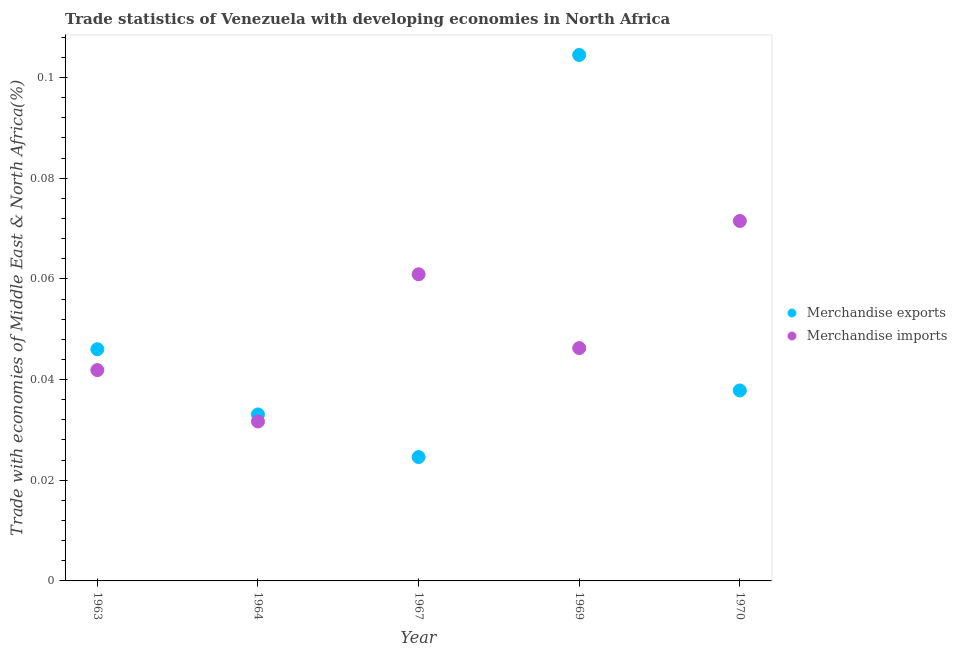What is the merchandise imports in 1969?
Give a very brief answer. 0.05. Across all years, what is the maximum merchandise exports?
Your answer should be very brief. 0.1. Across all years, what is the minimum merchandise imports?
Your answer should be very brief. 0.03. In which year was the merchandise exports maximum?
Keep it short and to the point. 1969. In which year was the merchandise exports minimum?
Ensure brevity in your answer.  1967. What is the total merchandise exports in the graph?
Make the answer very short. 0.25. What is the difference between the merchandise imports in 1967 and that in 1970?
Keep it short and to the point. -0.01. What is the difference between the merchandise exports in 1967 and the merchandise imports in 1970?
Your answer should be very brief. -0.05. What is the average merchandise imports per year?
Your answer should be compact. 0.05. In the year 1963, what is the difference between the merchandise imports and merchandise exports?
Ensure brevity in your answer.  -0. What is the ratio of the merchandise imports in 1967 to that in 1969?
Offer a terse response. 1.32. Is the merchandise exports in 1967 less than that in 1969?
Your answer should be compact. Yes. Is the difference between the merchandise exports in 1963 and 1970 greater than the difference between the merchandise imports in 1963 and 1970?
Your answer should be compact. Yes. What is the difference between the highest and the second highest merchandise exports?
Your response must be concise. 0.06. What is the difference between the highest and the lowest merchandise imports?
Your answer should be compact. 0.04. In how many years, is the merchandise exports greater than the average merchandise exports taken over all years?
Your answer should be compact. 1. Is the sum of the merchandise imports in 1967 and 1970 greater than the maximum merchandise exports across all years?
Your answer should be compact. Yes. Does the merchandise exports monotonically increase over the years?
Keep it short and to the point. No. Is the merchandise imports strictly greater than the merchandise exports over the years?
Give a very brief answer. No. Is the merchandise exports strictly less than the merchandise imports over the years?
Your response must be concise. No. Are the values on the major ticks of Y-axis written in scientific E-notation?
Your response must be concise. No. Does the graph contain any zero values?
Offer a very short reply. No. Does the graph contain grids?
Make the answer very short. No. How many legend labels are there?
Ensure brevity in your answer.  2. What is the title of the graph?
Give a very brief answer. Trade statistics of Venezuela with developing economies in North Africa. Does "constant 2005 US$" appear as one of the legend labels in the graph?
Give a very brief answer. No. What is the label or title of the Y-axis?
Ensure brevity in your answer.  Trade with economies of Middle East & North Africa(%). What is the Trade with economies of Middle East & North Africa(%) in Merchandise exports in 1963?
Your response must be concise. 0.05. What is the Trade with economies of Middle East & North Africa(%) in Merchandise imports in 1963?
Keep it short and to the point. 0.04. What is the Trade with economies of Middle East & North Africa(%) in Merchandise exports in 1964?
Make the answer very short. 0.03. What is the Trade with economies of Middle East & North Africa(%) of Merchandise imports in 1964?
Provide a short and direct response. 0.03. What is the Trade with economies of Middle East & North Africa(%) of Merchandise exports in 1967?
Provide a succinct answer. 0.02. What is the Trade with economies of Middle East & North Africa(%) in Merchandise imports in 1967?
Offer a terse response. 0.06. What is the Trade with economies of Middle East & North Africa(%) of Merchandise exports in 1969?
Your answer should be very brief. 0.1. What is the Trade with economies of Middle East & North Africa(%) in Merchandise imports in 1969?
Your answer should be very brief. 0.05. What is the Trade with economies of Middle East & North Africa(%) of Merchandise exports in 1970?
Offer a terse response. 0.04. What is the Trade with economies of Middle East & North Africa(%) of Merchandise imports in 1970?
Ensure brevity in your answer.  0.07. Across all years, what is the maximum Trade with economies of Middle East & North Africa(%) of Merchandise exports?
Provide a short and direct response. 0.1. Across all years, what is the maximum Trade with economies of Middle East & North Africa(%) in Merchandise imports?
Keep it short and to the point. 0.07. Across all years, what is the minimum Trade with economies of Middle East & North Africa(%) in Merchandise exports?
Ensure brevity in your answer.  0.02. Across all years, what is the minimum Trade with economies of Middle East & North Africa(%) in Merchandise imports?
Keep it short and to the point. 0.03. What is the total Trade with economies of Middle East & North Africa(%) of Merchandise exports in the graph?
Ensure brevity in your answer.  0.25. What is the total Trade with economies of Middle East & North Africa(%) of Merchandise imports in the graph?
Offer a very short reply. 0.25. What is the difference between the Trade with economies of Middle East & North Africa(%) of Merchandise exports in 1963 and that in 1964?
Your answer should be compact. 0.01. What is the difference between the Trade with economies of Middle East & North Africa(%) of Merchandise imports in 1963 and that in 1964?
Your response must be concise. 0.01. What is the difference between the Trade with economies of Middle East & North Africa(%) in Merchandise exports in 1963 and that in 1967?
Make the answer very short. 0.02. What is the difference between the Trade with economies of Middle East & North Africa(%) of Merchandise imports in 1963 and that in 1967?
Provide a succinct answer. -0.02. What is the difference between the Trade with economies of Middle East & North Africa(%) in Merchandise exports in 1963 and that in 1969?
Your answer should be compact. -0.06. What is the difference between the Trade with economies of Middle East & North Africa(%) in Merchandise imports in 1963 and that in 1969?
Keep it short and to the point. -0. What is the difference between the Trade with economies of Middle East & North Africa(%) of Merchandise exports in 1963 and that in 1970?
Offer a very short reply. 0.01. What is the difference between the Trade with economies of Middle East & North Africa(%) in Merchandise imports in 1963 and that in 1970?
Your response must be concise. -0.03. What is the difference between the Trade with economies of Middle East & North Africa(%) in Merchandise exports in 1964 and that in 1967?
Provide a succinct answer. 0.01. What is the difference between the Trade with economies of Middle East & North Africa(%) in Merchandise imports in 1964 and that in 1967?
Your answer should be very brief. -0.03. What is the difference between the Trade with economies of Middle East & North Africa(%) in Merchandise exports in 1964 and that in 1969?
Give a very brief answer. -0.07. What is the difference between the Trade with economies of Middle East & North Africa(%) of Merchandise imports in 1964 and that in 1969?
Offer a very short reply. -0.01. What is the difference between the Trade with economies of Middle East & North Africa(%) of Merchandise exports in 1964 and that in 1970?
Give a very brief answer. -0. What is the difference between the Trade with economies of Middle East & North Africa(%) in Merchandise imports in 1964 and that in 1970?
Make the answer very short. -0.04. What is the difference between the Trade with economies of Middle East & North Africa(%) in Merchandise exports in 1967 and that in 1969?
Ensure brevity in your answer.  -0.08. What is the difference between the Trade with economies of Middle East & North Africa(%) of Merchandise imports in 1967 and that in 1969?
Offer a terse response. 0.01. What is the difference between the Trade with economies of Middle East & North Africa(%) of Merchandise exports in 1967 and that in 1970?
Provide a succinct answer. -0.01. What is the difference between the Trade with economies of Middle East & North Africa(%) of Merchandise imports in 1967 and that in 1970?
Offer a terse response. -0.01. What is the difference between the Trade with economies of Middle East & North Africa(%) of Merchandise exports in 1969 and that in 1970?
Give a very brief answer. 0.07. What is the difference between the Trade with economies of Middle East & North Africa(%) of Merchandise imports in 1969 and that in 1970?
Your answer should be compact. -0.03. What is the difference between the Trade with economies of Middle East & North Africa(%) in Merchandise exports in 1963 and the Trade with economies of Middle East & North Africa(%) in Merchandise imports in 1964?
Keep it short and to the point. 0.01. What is the difference between the Trade with economies of Middle East & North Africa(%) of Merchandise exports in 1963 and the Trade with economies of Middle East & North Africa(%) of Merchandise imports in 1967?
Your response must be concise. -0.01. What is the difference between the Trade with economies of Middle East & North Africa(%) of Merchandise exports in 1963 and the Trade with economies of Middle East & North Africa(%) of Merchandise imports in 1969?
Keep it short and to the point. -0. What is the difference between the Trade with economies of Middle East & North Africa(%) of Merchandise exports in 1963 and the Trade with economies of Middle East & North Africa(%) of Merchandise imports in 1970?
Offer a very short reply. -0.03. What is the difference between the Trade with economies of Middle East & North Africa(%) in Merchandise exports in 1964 and the Trade with economies of Middle East & North Africa(%) in Merchandise imports in 1967?
Ensure brevity in your answer.  -0.03. What is the difference between the Trade with economies of Middle East & North Africa(%) of Merchandise exports in 1964 and the Trade with economies of Middle East & North Africa(%) of Merchandise imports in 1969?
Ensure brevity in your answer.  -0.01. What is the difference between the Trade with economies of Middle East & North Africa(%) in Merchandise exports in 1964 and the Trade with economies of Middle East & North Africa(%) in Merchandise imports in 1970?
Provide a succinct answer. -0.04. What is the difference between the Trade with economies of Middle East & North Africa(%) in Merchandise exports in 1967 and the Trade with economies of Middle East & North Africa(%) in Merchandise imports in 1969?
Provide a short and direct response. -0.02. What is the difference between the Trade with economies of Middle East & North Africa(%) in Merchandise exports in 1967 and the Trade with economies of Middle East & North Africa(%) in Merchandise imports in 1970?
Provide a succinct answer. -0.05. What is the difference between the Trade with economies of Middle East & North Africa(%) of Merchandise exports in 1969 and the Trade with economies of Middle East & North Africa(%) of Merchandise imports in 1970?
Offer a very short reply. 0.03. What is the average Trade with economies of Middle East & North Africa(%) of Merchandise exports per year?
Your answer should be very brief. 0.05. What is the average Trade with economies of Middle East & North Africa(%) of Merchandise imports per year?
Provide a succinct answer. 0.05. In the year 1963, what is the difference between the Trade with economies of Middle East & North Africa(%) in Merchandise exports and Trade with economies of Middle East & North Africa(%) in Merchandise imports?
Offer a terse response. 0. In the year 1964, what is the difference between the Trade with economies of Middle East & North Africa(%) of Merchandise exports and Trade with economies of Middle East & North Africa(%) of Merchandise imports?
Offer a very short reply. 0. In the year 1967, what is the difference between the Trade with economies of Middle East & North Africa(%) of Merchandise exports and Trade with economies of Middle East & North Africa(%) of Merchandise imports?
Your answer should be very brief. -0.04. In the year 1969, what is the difference between the Trade with economies of Middle East & North Africa(%) of Merchandise exports and Trade with economies of Middle East & North Africa(%) of Merchandise imports?
Your answer should be very brief. 0.06. In the year 1970, what is the difference between the Trade with economies of Middle East & North Africa(%) in Merchandise exports and Trade with economies of Middle East & North Africa(%) in Merchandise imports?
Your response must be concise. -0.03. What is the ratio of the Trade with economies of Middle East & North Africa(%) in Merchandise exports in 1963 to that in 1964?
Offer a very short reply. 1.39. What is the ratio of the Trade with economies of Middle East & North Africa(%) in Merchandise imports in 1963 to that in 1964?
Offer a very short reply. 1.32. What is the ratio of the Trade with economies of Middle East & North Africa(%) in Merchandise exports in 1963 to that in 1967?
Provide a succinct answer. 1.87. What is the ratio of the Trade with economies of Middle East & North Africa(%) in Merchandise imports in 1963 to that in 1967?
Make the answer very short. 0.69. What is the ratio of the Trade with economies of Middle East & North Africa(%) of Merchandise exports in 1963 to that in 1969?
Keep it short and to the point. 0.44. What is the ratio of the Trade with economies of Middle East & North Africa(%) of Merchandise imports in 1963 to that in 1969?
Provide a short and direct response. 0.91. What is the ratio of the Trade with economies of Middle East & North Africa(%) of Merchandise exports in 1963 to that in 1970?
Make the answer very short. 1.22. What is the ratio of the Trade with economies of Middle East & North Africa(%) of Merchandise imports in 1963 to that in 1970?
Your answer should be compact. 0.59. What is the ratio of the Trade with economies of Middle East & North Africa(%) in Merchandise exports in 1964 to that in 1967?
Make the answer very short. 1.34. What is the ratio of the Trade with economies of Middle East & North Africa(%) of Merchandise imports in 1964 to that in 1967?
Keep it short and to the point. 0.52. What is the ratio of the Trade with economies of Middle East & North Africa(%) in Merchandise exports in 1964 to that in 1969?
Keep it short and to the point. 0.32. What is the ratio of the Trade with economies of Middle East & North Africa(%) of Merchandise imports in 1964 to that in 1969?
Offer a terse response. 0.68. What is the ratio of the Trade with economies of Middle East & North Africa(%) in Merchandise exports in 1964 to that in 1970?
Offer a terse response. 0.87. What is the ratio of the Trade with economies of Middle East & North Africa(%) of Merchandise imports in 1964 to that in 1970?
Your answer should be very brief. 0.44. What is the ratio of the Trade with economies of Middle East & North Africa(%) of Merchandise exports in 1967 to that in 1969?
Provide a short and direct response. 0.24. What is the ratio of the Trade with economies of Middle East & North Africa(%) of Merchandise imports in 1967 to that in 1969?
Provide a short and direct response. 1.32. What is the ratio of the Trade with economies of Middle East & North Africa(%) of Merchandise exports in 1967 to that in 1970?
Provide a short and direct response. 0.65. What is the ratio of the Trade with economies of Middle East & North Africa(%) in Merchandise imports in 1967 to that in 1970?
Your answer should be very brief. 0.85. What is the ratio of the Trade with economies of Middle East & North Africa(%) in Merchandise exports in 1969 to that in 1970?
Make the answer very short. 2.76. What is the ratio of the Trade with economies of Middle East & North Africa(%) in Merchandise imports in 1969 to that in 1970?
Your answer should be compact. 0.65. What is the difference between the highest and the second highest Trade with economies of Middle East & North Africa(%) of Merchandise exports?
Offer a very short reply. 0.06. What is the difference between the highest and the second highest Trade with economies of Middle East & North Africa(%) in Merchandise imports?
Ensure brevity in your answer.  0.01. What is the difference between the highest and the lowest Trade with economies of Middle East & North Africa(%) of Merchandise exports?
Provide a short and direct response. 0.08. What is the difference between the highest and the lowest Trade with economies of Middle East & North Africa(%) of Merchandise imports?
Offer a very short reply. 0.04. 